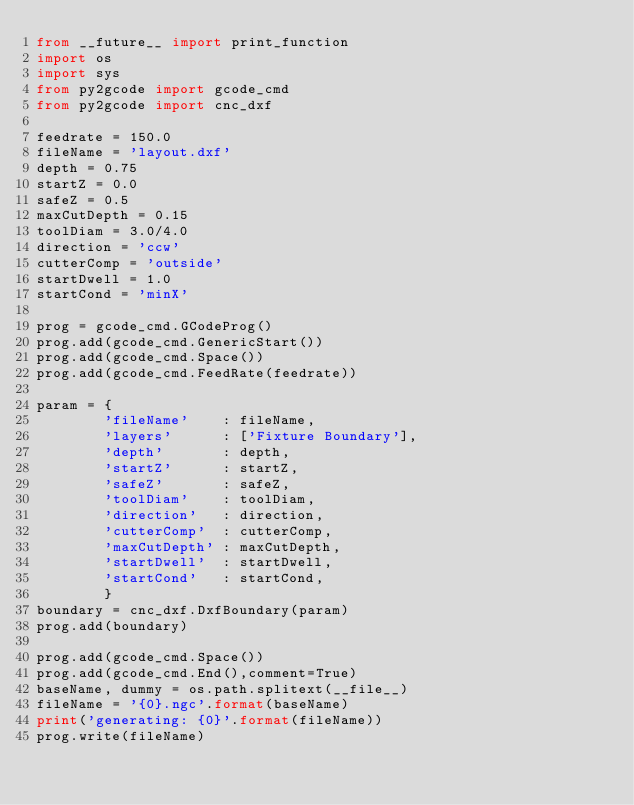<code> <loc_0><loc_0><loc_500><loc_500><_Python_>from __future__ import print_function
import os 
import sys
from py2gcode import gcode_cmd
from py2gcode import cnc_dxf

feedrate = 150.0
fileName = 'layout.dxf'
depth = 0.75
startZ = 0.0
safeZ = 0.5
maxCutDepth = 0.15
toolDiam = 3.0/4.0 
direction = 'ccw'
cutterComp = 'outside'
startDwell = 1.0
startCond = 'minX'

prog = gcode_cmd.GCodeProg()
prog.add(gcode_cmd.GenericStart())
prog.add(gcode_cmd.Space())
prog.add(gcode_cmd.FeedRate(feedrate))

param = {
        'fileName'    : fileName,
        'layers'      : ['Fixture Boundary'],
        'depth'       : depth,
        'startZ'      : startZ,
        'safeZ'       : safeZ,
        'toolDiam'    : toolDiam,
        'direction'   : direction,
        'cutterComp'  : cutterComp,
        'maxCutDepth' : maxCutDepth,
        'startDwell'  : startDwell, 
        'startCond'   : startCond,
        }
boundary = cnc_dxf.DxfBoundary(param)
prog.add(boundary)

prog.add(gcode_cmd.Space())
prog.add(gcode_cmd.End(),comment=True)
baseName, dummy = os.path.splitext(__file__)
fileName = '{0}.ngc'.format(baseName)
print('generating: {0}'.format(fileName))
prog.write(fileName)
</code> 